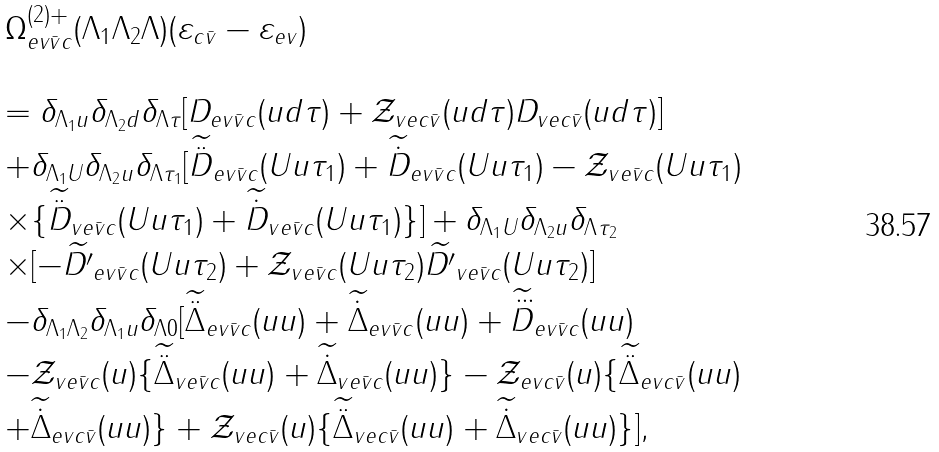<formula> <loc_0><loc_0><loc_500><loc_500>\begin{array} { l } \Omega _ { e v \bar { v } c } ^ { ( 2 ) + } ( \Lambda _ { 1 } \Lambda _ { 2 } \Lambda ) ( \varepsilon _ { c \bar { v } } - \varepsilon _ { e v } ) \\ \\ = \delta _ { \Lambda _ { 1 } u } \delta _ { \Lambda _ { 2 } d } \delta _ { \Lambda \tau } [ D _ { e v \bar { v } c } ( u d \tau ) + \mathcal { Z } _ { v e c \bar { v } } ( u d \tau ) D _ { v e c \bar { v } } ( u d \tau ) ] \\ + \delta _ { \Lambda _ { 1 } U } \delta _ { \Lambda _ { 2 } u } \delta _ { \Lambda \tau _ { 1 } } [ \widetilde { \ddot { D } } _ { e v \bar { v } c } ( U u \tau _ { 1 } ) + \widetilde { \dot { D } } _ { e v \bar { v } c } ( U u \tau _ { 1 } ) - \mathcal { Z } _ { v e \bar { v } c } ( U u \tau _ { 1 } ) \\ \times \{ \widetilde { \ddot { D } } _ { v e \bar { v } c } ( U u \tau _ { 1 } ) + \widetilde { \dot { D } } _ { v e \bar { v } c } ( U u \tau _ { 1 } ) \} ] + \delta _ { \Lambda _ { 1 } U } \delta _ { \Lambda _ { 2 } u } \delta _ { \Lambda \tau _ { 2 } } \\ \times [ - \widetilde { D ^ { \prime } } _ { e v \bar { v } c } ( U u \tau _ { 2 } ) + \mathcal { Z } _ { v e \bar { v } c } ( U u \tau _ { 2 } ) \widetilde { D ^ { \prime } } _ { v e \bar { v } c } ( U u \tau _ { 2 } ) ] \\ - \delta _ { \Lambda _ { 1 } \Lambda _ { 2 } } \delta _ { \Lambda _ { 1 } u } \delta _ { \Lambda 0 } [ \widetilde { \ddot { \Delta } } _ { e v \bar { v } c } ( u u ) + \widetilde { \dot { \Delta } } _ { e v \bar { v } c } ( u u ) + \widetilde { \dddot { D } } _ { e v \bar { v } c } ( u u ) \\ - \mathcal { Z } _ { v e \bar { v } c } ( u ) \{ \widetilde { \ddot { \Delta } } _ { v e \bar { v } c } ( u u ) + \widetilde { \dot { \Delta } } _ { v e \bar { v } c } ( u u ) \} - \mathcal { Z } _ { e v c \bar { v } } ( u ) \{ \widetilde { \ddot { \Delta } } _ { e v c \bar { v } } ( u u ) \\ + \widetilde { \dot { \Delta } } _ { e v c \bar { v } } ( u u ) \} + \mathcal { Z } _ { v e c \bar { v } } ( u ) \{ \widetilde { \ddot { \Delta } } _ { v e c \bar { v } } ( u u ) + \widetilde { \dot { \Delta } } _ { v e c \bar { v } } ( u u ) \} ] , \end{array}</formula> 